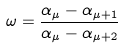Convert formula to latex. <formula><loc_0><loc_0><loc_500><loc_500>\omega = \frac { \alpha _ { \mu } - \alpha _ { \mu + 1 } } { \alpha _ { \mu } - \alpha _ { \mu + 2 } }</formula> 